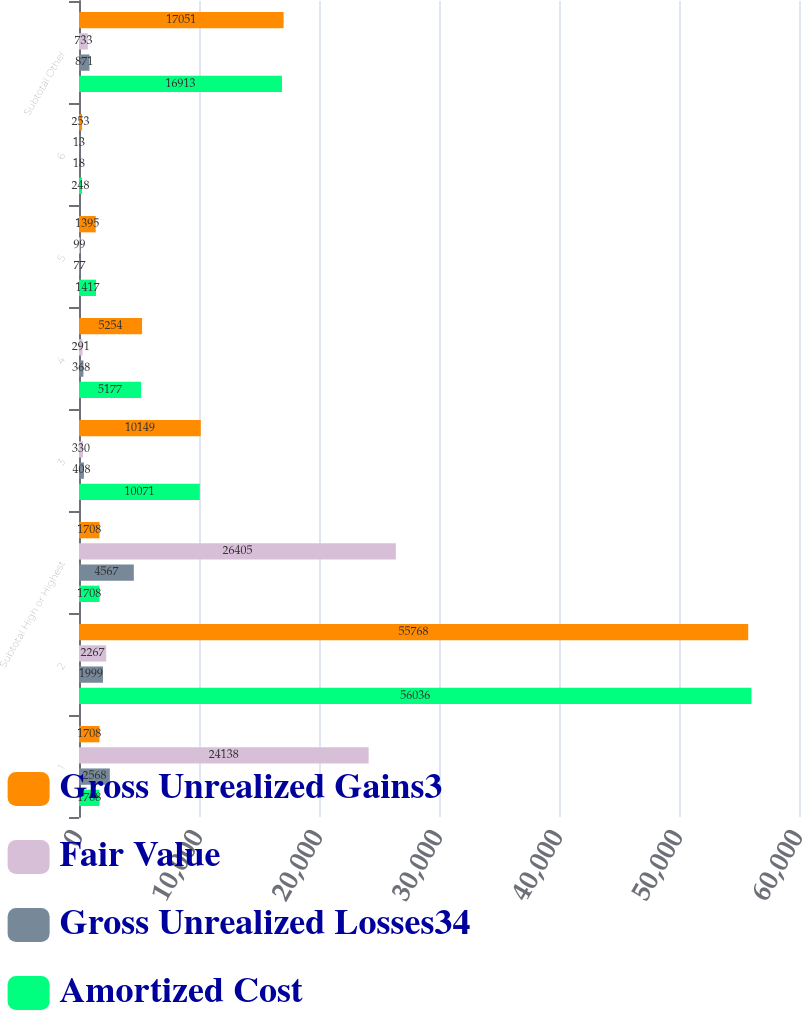<chart> <loc_0><loc_0><loc_500><loc_500><stacked_bar_chart><ecel><fcel>1<fcel>2<fcel>Subtotal High or Highest<fcel>3<fcel>4<fcel>5<fcel>6<fcel>Subtotal Other<nl><fcel>Gross Unrealized Gains3<fcel>1708<fcel>55768<fcel>1708<fcel>10149<fcel>5254<fcel>1395<fcel>253<fcel>17051<nl><fcel>Fair Value<fcel>24138<fcel>2267<fcel>26405<fcel>330<fcel>291<fcel>99<fcel>13<fcel>733<nl><fcel>Gross Unrealized Losses34<fcel>2568<fcel>1999<fcel>4567<fcel>408<fcel>368<fcel>77<fcel>18<fcel>871<nl><fcel>Amortized Cost<fcel>1708<fcel>56036<fcel>1708<fcel>10071<fcel>5177<fcel>1417<fcel>248<fcel>16913<nl></chart> 